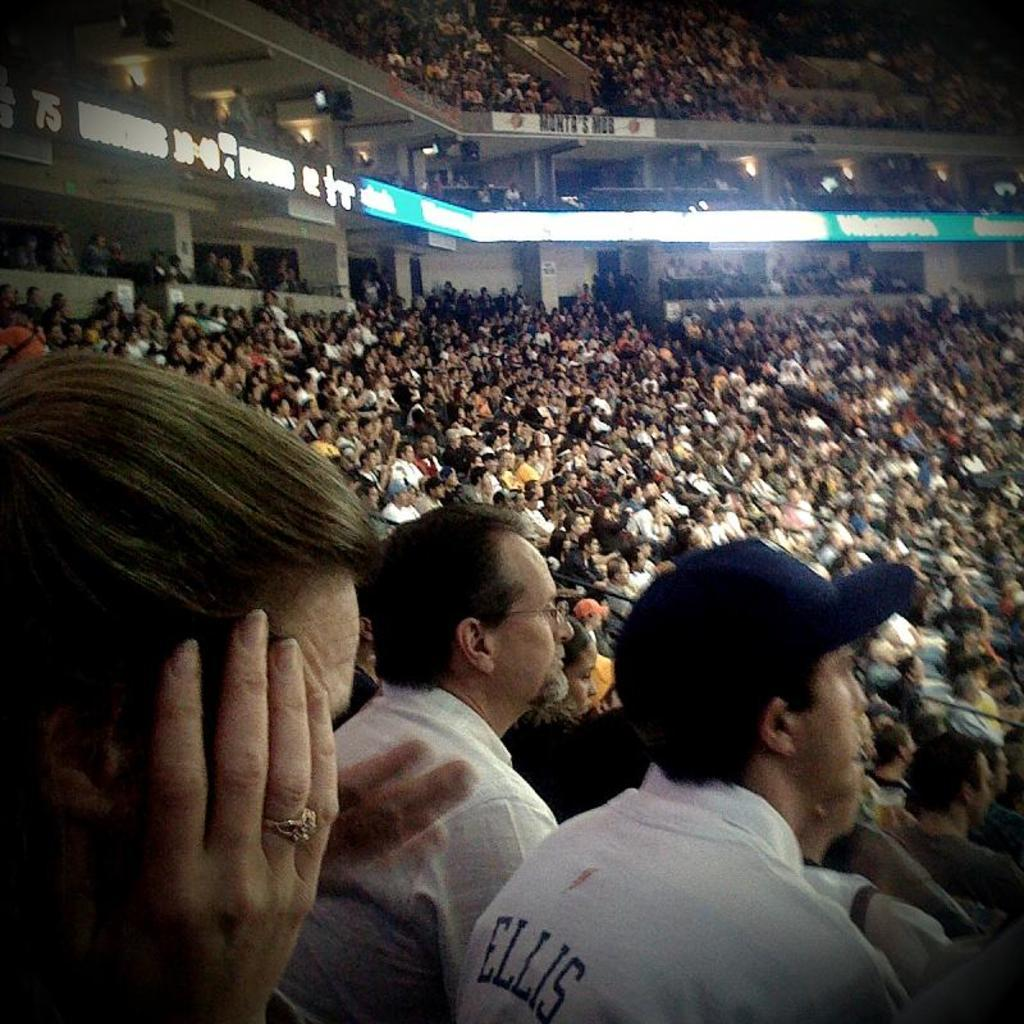What can be seen in the image? There is an audience in the image. How are the people in the audience positioned? The audience is sitting on chairs. What is on the walls in the image? There is a hoarding on the walls in the image. Can you describe any other objects present in the image? There are other objects present in the image, but their specific details are not mentioned in the provided facts. What company is responsible for the shocking fact displayed on the hoarding in the image? There is no mention of a company or a shocking fact in the provided facts, so it is not possible to answer this question. 